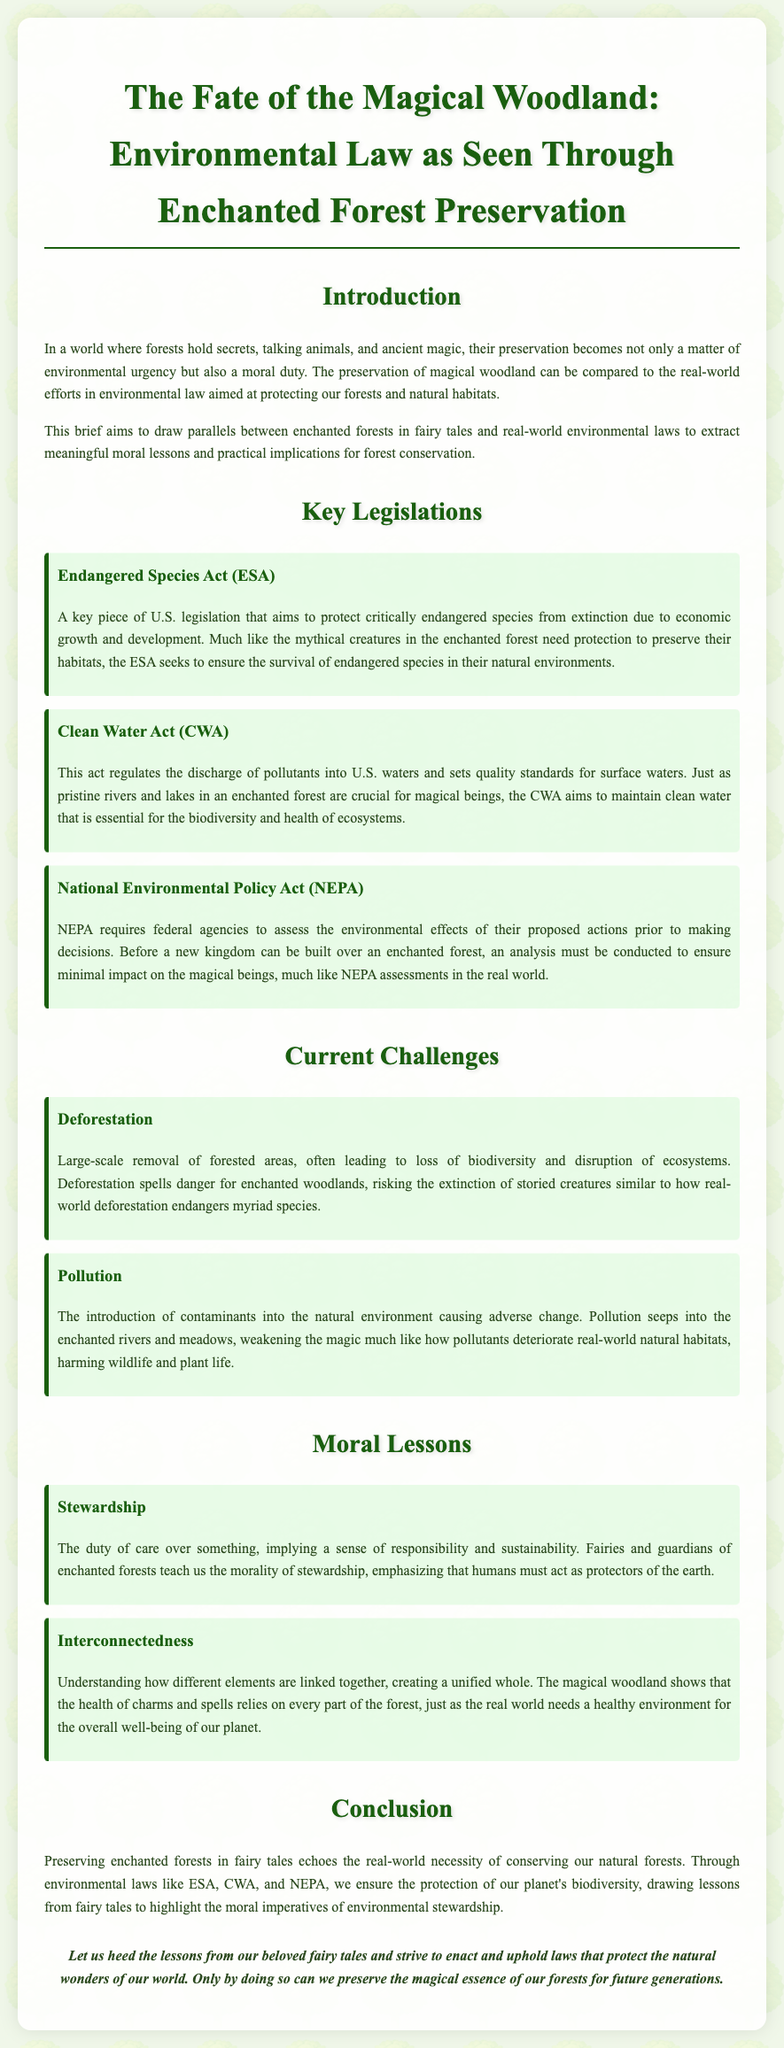What is the title of the document? The title is stated at the beginning and summarizes the main focus of the brief.
Answer: The Fate of the Magical Woodland: Environmental Law as Seen Through Enchanted Forest Preservation What is the purpose of the Clean Water Act? The document explains that the CWA aims to maintain clean water essential for ecosystems.
Answer: Regulates pollutants in U.S. waters What does NEPA require from federal agencies? The document outlines that NEPA requires an assessment of environmental effects before decisions.
Answer: Environmental assessments What current challenge does the document mention related to forest preservation? The document discusses the impact of large-scale forest removal on biodiversity.
Answer: Deforestation What moral lesson is associated with the concept of stewardship? The brief presents stewardship as a moral duty to care for the environment.
Answer: Responsibility and sustainability Which act is focused on protecting critically endangered species? The document specifies a legislation that aims to prevent the extinction of species.
Answer: Endangered Species Act How does the document describe the relationship between elements in an ecosystem? The document emphasizes that different elements are interconnected to create a healthy environment.
Answer: Interconnectedness What is emphasized as essential for the survival of mystical creatures in fairy tales? The document draws a parallel between magical creatures and the need for real-world species protection.
Answer: Habitat preservation What is the concluding message of the brief? The conclusion advises adherence to moral lessons from fairy tales for environmental protection.
Answer: Preserve natural wonders for future generations 